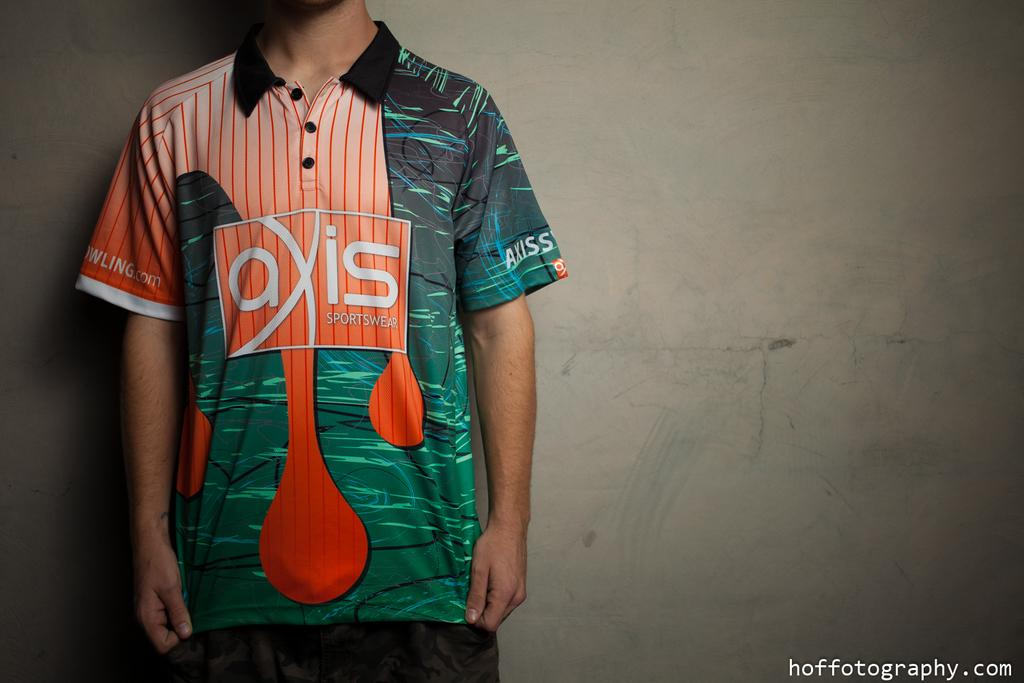<image>
Give a short and clear explanation of the subsequent image. a man with the word axis on his shirt 